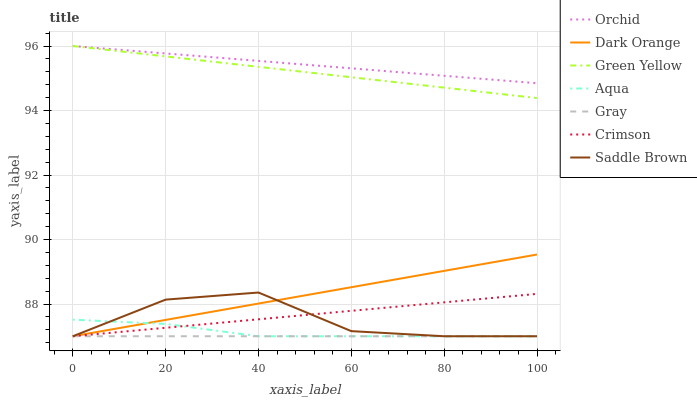Does Gray have the minimum area under the curve?
Answer yes or no. Yes. Does Orchid have the maximum area under the curve?
Answer yes or no. Yes. Does Aqua have the minimum area under the curve?
Answer yes or no. No. Does Aqua have the maximum area under the curve?
Answer yes or no. No. Is Gray the smoothest?
Answer yes or no. Yes. Is Saddle Brown the roughest?
Answer yes or no. Yes. Is Aqua the smoothest?
Answer yes or no. No. Is Aqua the roughest?
Answer yes or no. No. Does Dark Orange have the lowest value?
Answer yes or no. Yes. Does Green Yellow have the lowest value?
Answer yes or no. No. Does Orchid have the highest value?
Answer yes or no. Yes. Does Aqua have the highest value?
Answer yes or no. No. Is Gray less than Orchid?
Answer yes or no. Yes. Is Orchid greater than Aqua?
Answer yes or no. Yes. Does Dark Orange intersect Aqua?
Answer yes or no. Yes. Is Dark Orange less than Aqua?
Answer yes or no. No. Is Dark Orange greater than Aqua?
Answer yes or no. No. Does Gray intersect Orchid?
Answer yes or no. No. 